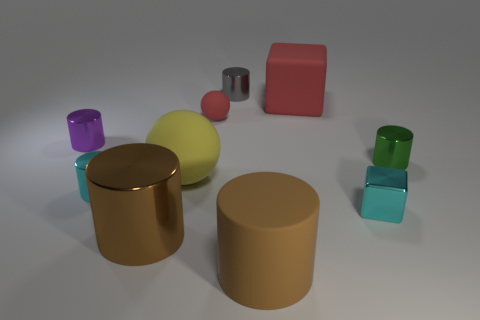What size is the object that is the same color as the big matte cube?
Offer a terse response. Small. There is a rubber sphere behind the small purple shiny cylinder; does it have the same color as the large thing that is behind the small purple metal thing?
Offer a terse response. Yes. There is a big matte thing in front of the small cyan cube; how many metallic objects are right of it?
Make the answer very short. 2. How many other things are there of the same size as the cyan cylinder?
Offer a very short reply. 5. Is the tiny matte thing the same color as the big rubber block?
Make the answer very short. Yes. There is a small metal object behind the small purple metallic thing; does it have the same shape as the small purple thing?
Your response must be concise. Yes. What number of shiny objects are both left of the large red rubber cube and in front of the tiny purple cylinder?
Offer a terse response. 2. What material is the tiny gray thing?
Your response must be concise. Metal. Is there anything else that has the same color as the big rubber ball?
Offer a terse response. No. Do the tiny gray cylinder and the tiny cyan cylinder have the same material?
Ensure brevity in your answer.  Yes. 